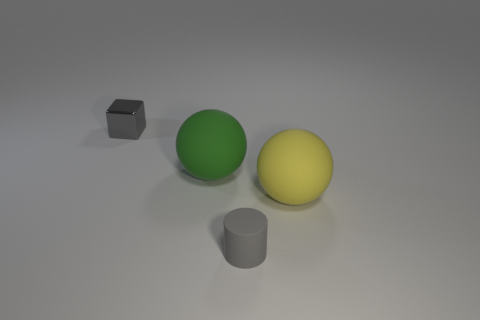Add 3 yellow shiny spheres. How many objects exist? 7 Subtract all cylinders. How many objects are left? 3 Subtract all small objects. Subtract all cyan rubber cylinders. How many objects are left? 2 Add 3 tiny objects. How many tiny objects are left? 5 Add 1 tiny yellow balls. How many tiny yellow balls exist? 1 Subtract 0 red balls. How many objects are left? 4 